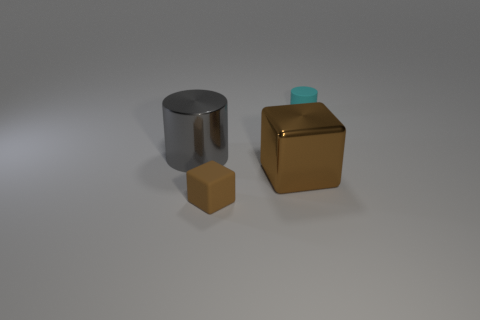The cylinder on the left side of the small thing that is left of the cyan matte object is made of what material?
Your answer should be compact. Metal. What is the color of the cube that is the same material as the gray object?
Make the answer very short. Brown. The matte thing that is the same color as the shiny block is what shape?
Make the answer very short. Cube. Is the size of the matte thing left of the tiny cyan matte thing the same as the rubber object behind the tiny block?
Your response must be concise. Yes. What number of cylinders are big things or gray objects?
Your response must be concise. 1. Does the brown block that is behind the tiny brown matte cube have the same material as the big cylinder?
Your response must be concise. Yes. How many other objects are there of the same size as the gray cylinder?
Your response must be concise. 1. What number of small things are brown rubber blocks or green metal cylinders?
Offer a very short reply. 1. Do the metal cube and the big cylinder have the same color?
Offer a very short reply. No. Are there more small rubber objects that are behind the large cylinder than small cylinders that are to the right of the matte cylinder?
Offer a very short reply. Yes. 